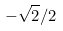<formula> <loc_0><loc_0><loc_500><loc_500>- \sqrt { 2 } / 2</formula> 